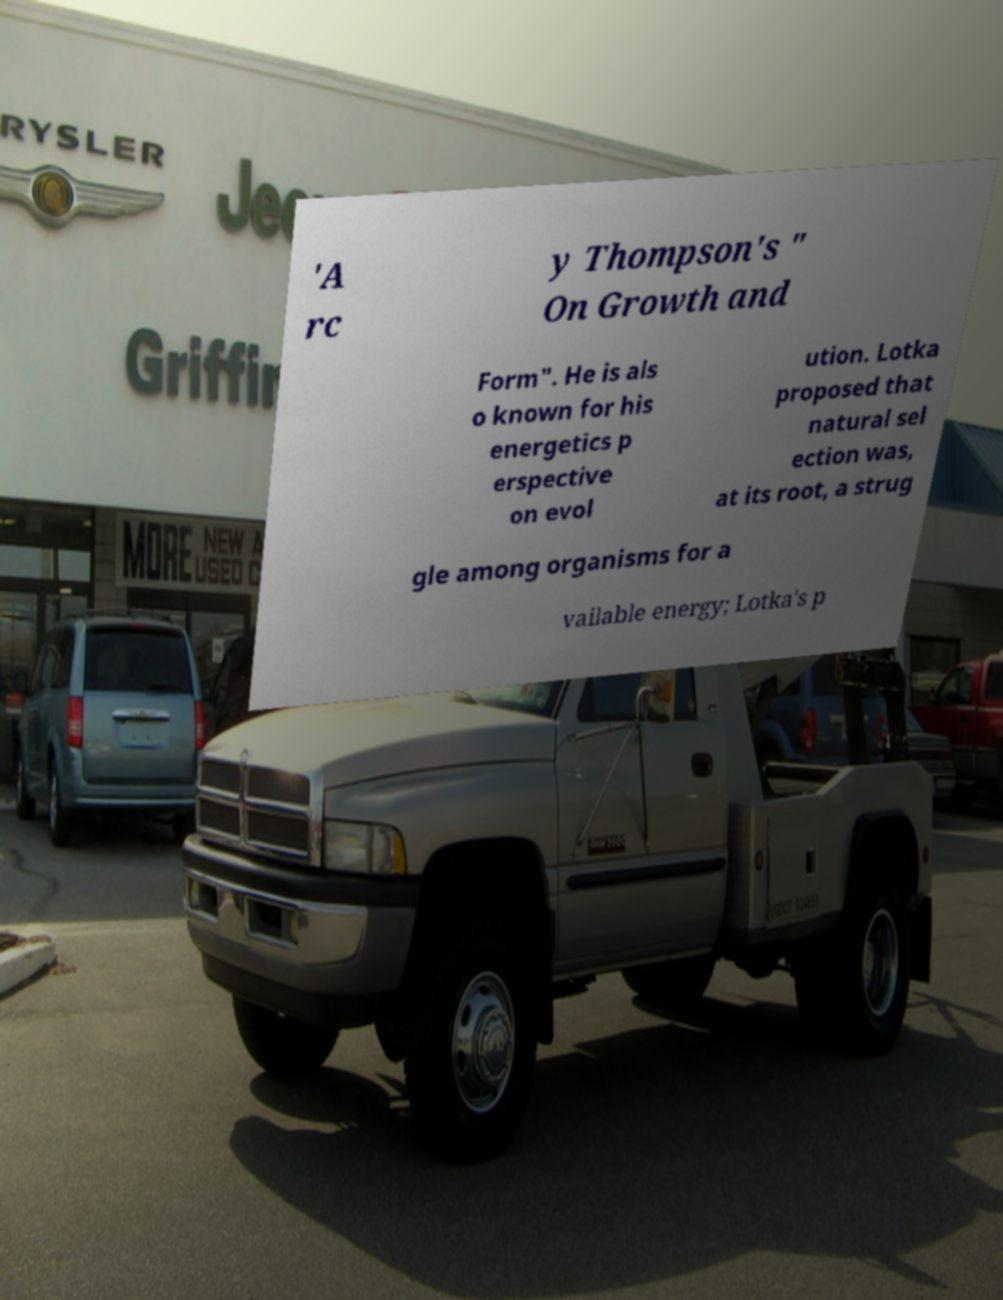What messages or text are displayed in this image? I need them in a readable, typed format. 'A rc y Thompson's " On Growth and Form". He is als o known for his energetics p erspective on evol ution. Lotka proposed that natural sel ection was, at its root, a strug gle among organisms for a vailable energy; Lotka's p 